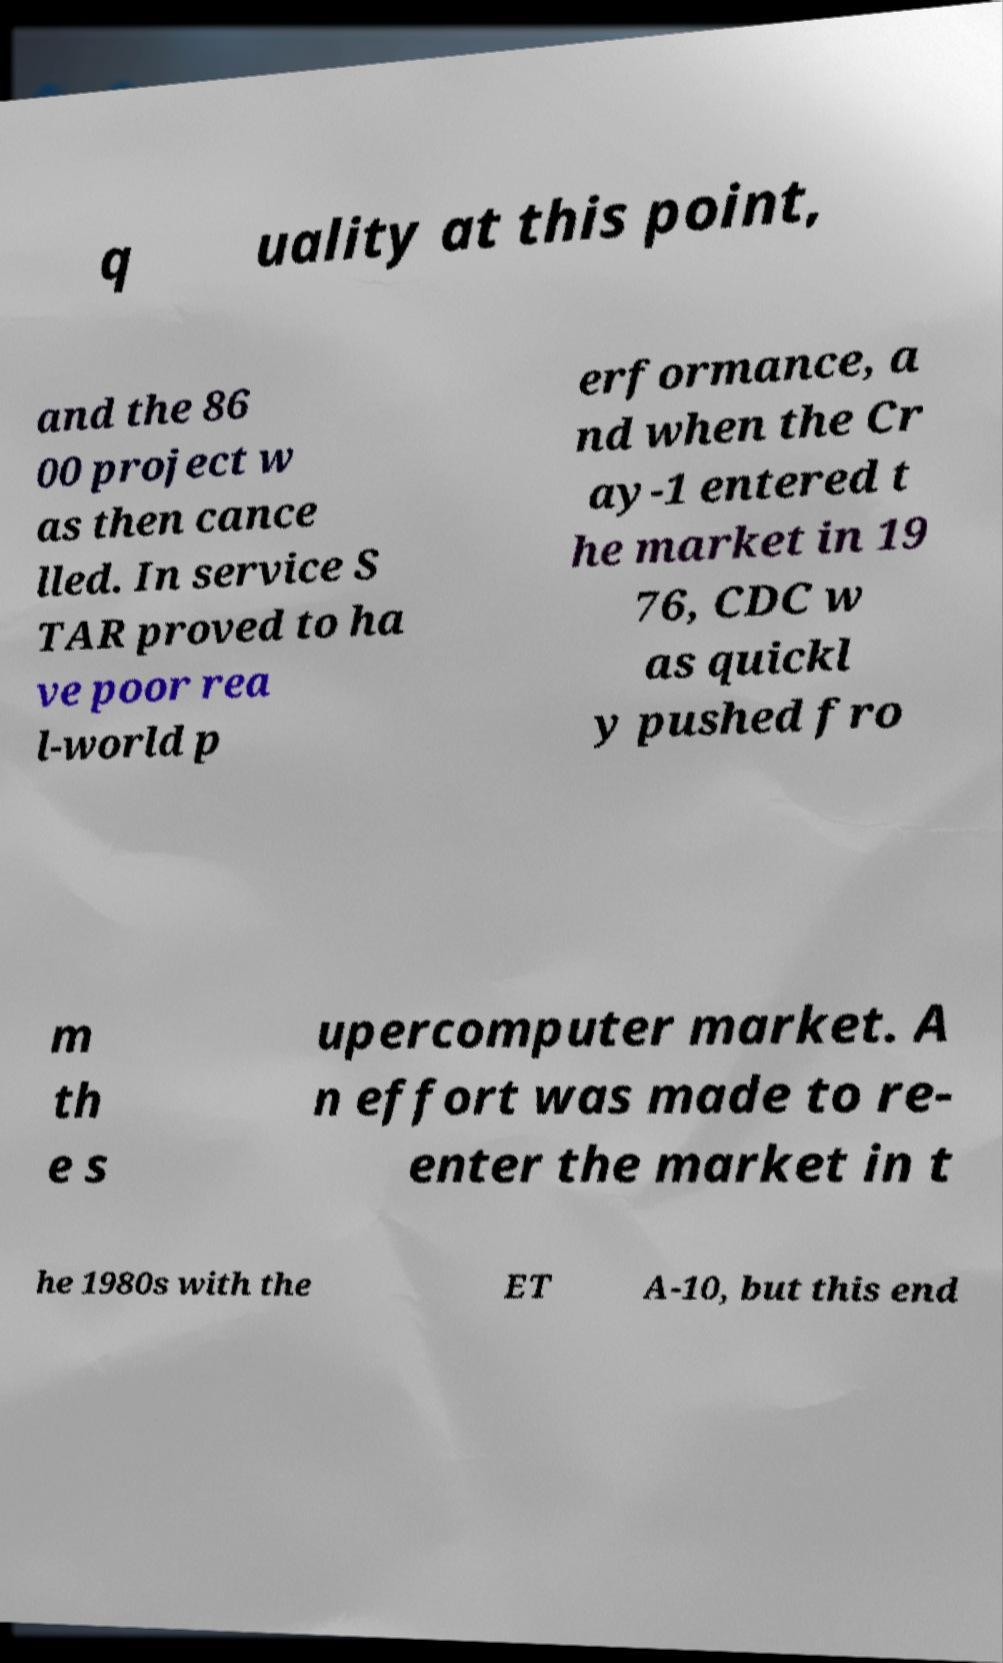Please identify and transcribe the text found in this image. q uality at this point, and the 86 00 project w as then cance lled. In service S TAR proved to ha ve poor rea l-world p erformance, a nd when the Cr ay-1 entered t he market in 19 76, CDC w as quickl y pushed fro m th e s upercomputer market. A n effort was made to re- enter the market in t he 1980s with the ET A-10, but this end 